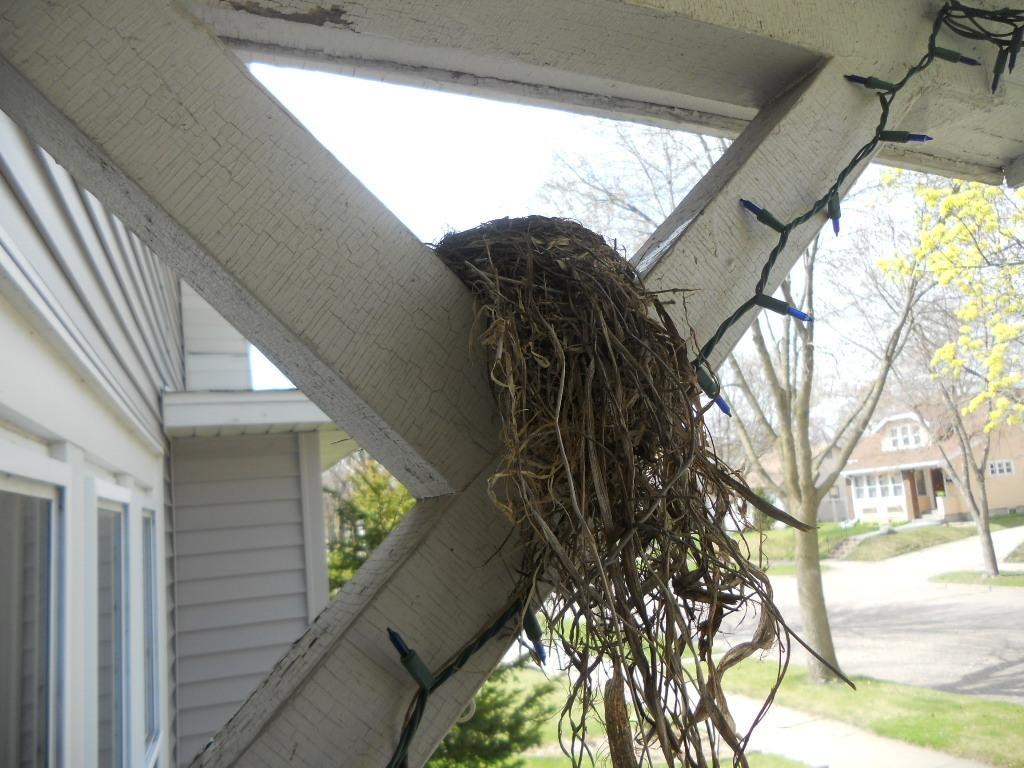What can be found in the image that is used by birds to lay eggs? There is a nest in the image that is used by birds to lay eggs. What type of structure can be seen in the image that separates areas or provides a boundary? There is a wooden fence in the image that separates areas or provides a boundary. What type of man-made structure is visible in the image? There is a building in the image that is a man-made structure. What part of the building can be seen in the image? The windows of the building are visible in the image. What type of illumination can be seen in the image? There are lights in the image that provide illumination. What type of utility can be seen in the image? There is a wire in the image that is a utility. What type of vegetation can be seen in the image? There are trees in the image that are a type of vegetation. What type of ground cover can be seen in the image? There is grass in the image that is a type of ground cover. What type of pathway can be seen in the image? There is a path in the image that is a type of pathway. What part of the natural environment is visible in the image? The sky is visible in the image. How many worms can be seen crawling on the building in the image? There are no worms visible in the image; the focus is on the nest, wooden fence, building, windows, lights, wire, trees, grass, path, and sky. What type of liquid is being poured from the sky in the image? There is no liquid being poured from the sky in the image; the sky is visible but not depicted as pouring any liquid. 